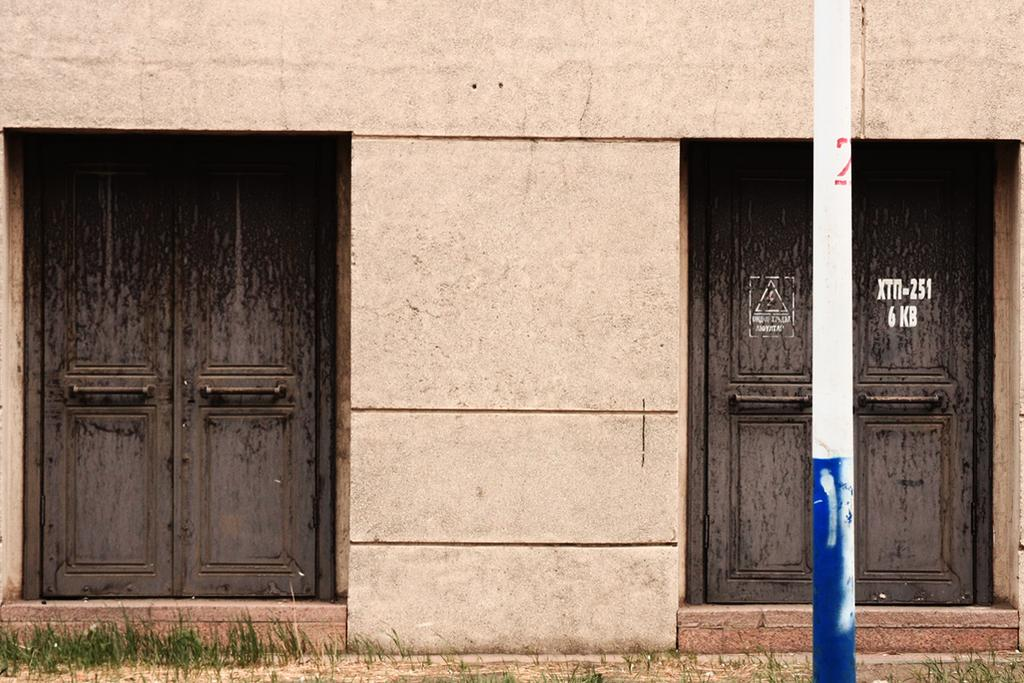What type of structure can be seen in the image? There is a wall in the image. Are there any openings in the wall? Yes, there are doors in the image. What else is present in the image besides the wall and doors? There is a pole and grass in the image. What type of wine is being served at the ant's party in the image? There is no wine or ant present in the image. What reason might someone have for placing a pole in the grass in the image? The image does not provide any information about the reason for placing the pole in the grass. 